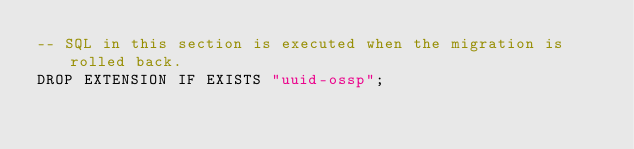Convert code to text. <code><loc_0><loc_0><loc_500><loc_500><_SQL_>-- SQL in this section is executed when the migration is rolled back.
DROP EXTENSION IF EXISTS "uuid-ossp";</code> 